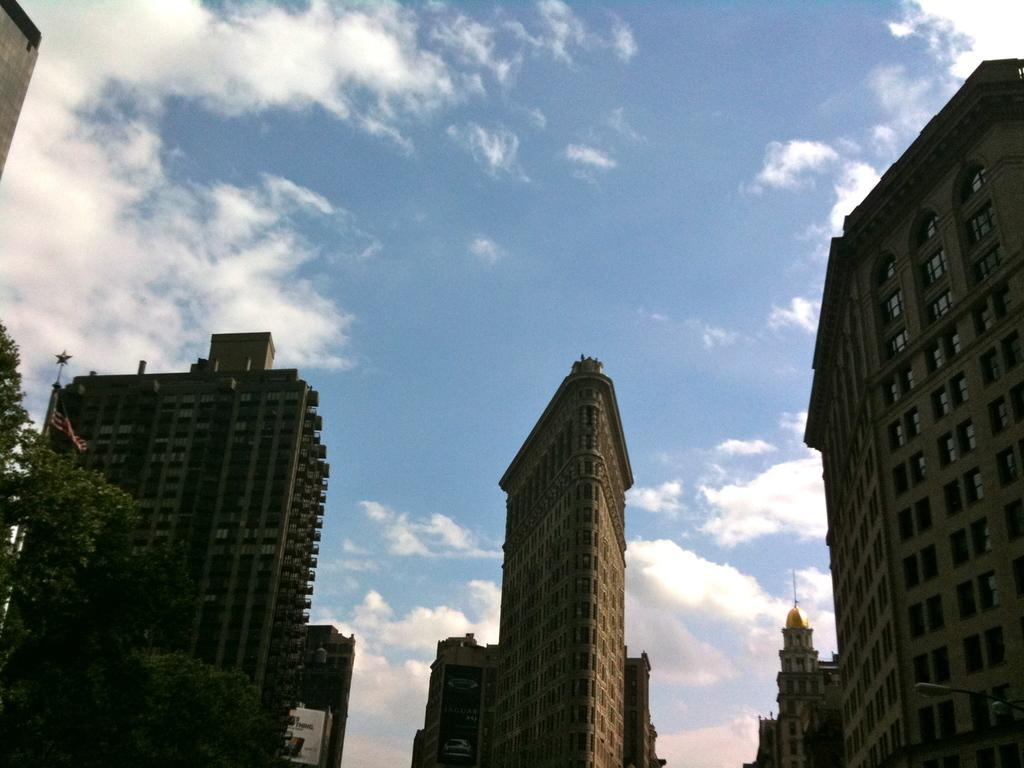What type of structures are visible in the image? There is a group of buildings with windows in the image. What can be seen on a pole in the image? There is a flag on a pole in the image. What type of vegetation is present in the image? There are trees in the image. What is visible in the background of the image? The sky is visible in the image. What is the condition of the sky in the image? The sky appears to be cloudy in the image. What type of suit is the tree wearing in the image? There are no suits present in the image, as it features buildings, a flag, trees, and a cloudy sky. What kind of bait is being used to catch fish in the image? There is no fishing or bait present in the image; it focuses on buildings, a flag, trees, and the sky. 